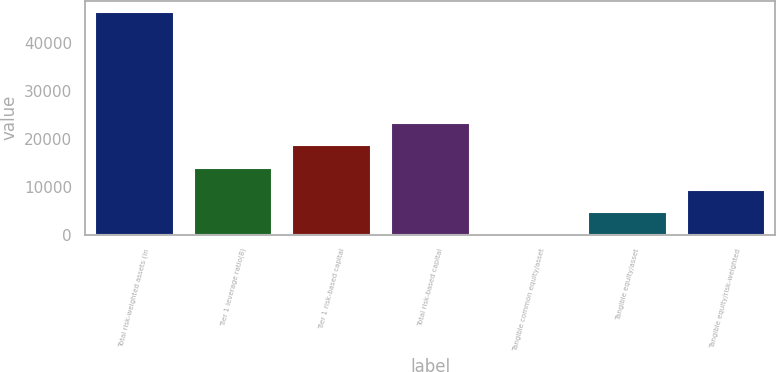Convert chart. <chart><loc_0><loc_0><loc_500><loc_500><bar_chart><fcel>Total risk-weighted assets (in<fcel>Tier 1 leverage ratio(8)<fcel>Tier 1 risk-based capital<fcel>Total risk-based capital<fcel>Tangible common equity/asset<fcel>Tangible equity/asset<fcel>Tangible equity/risk-weighted<nl><fcel>46602<fcel>13984<fcel>18643.7<fcel>23303.4<fcel>4.81<fcel>4664.53<fcel>9324.25<nl></chart> 